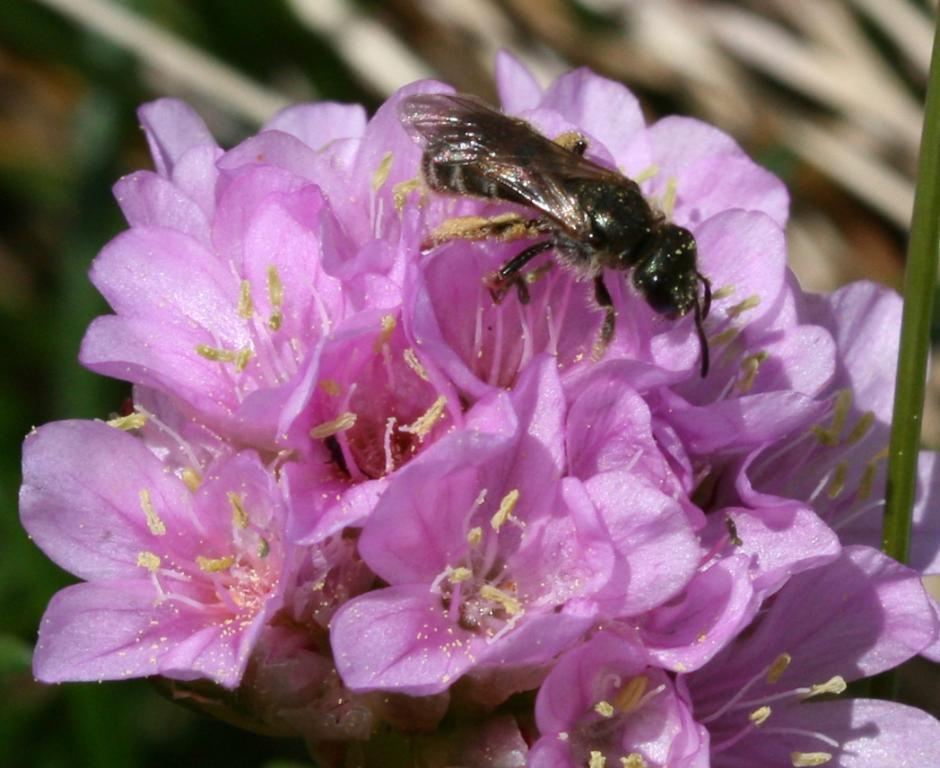What type of living organisms can be seen in the image? There are flowers and an insect in the image. Can you describe the insect's location in the image? The insect is on one of the flowers in the image. What can be observed about the background of the image? The background of the image is blurred. What type of song can be heard playing in the background of the image? There is no sound or song present in the image; it is a still photograph. 